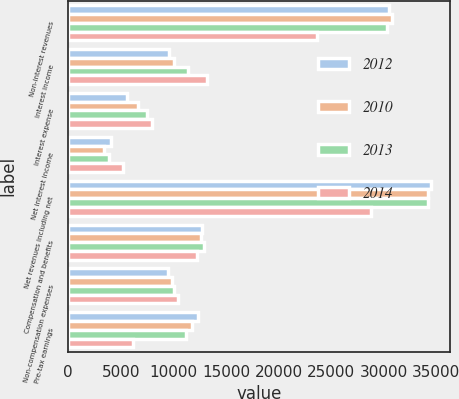Convert chart. <chart><loc_0><loc_0><loc_500><loc_500><stacked_bar_chart><ecel><fcel>Non-interest revenues<fcel>Interest income<fcel>Interest expense<fcel>Net interest income<fcel>Net revenues including net<fcel>Compensation and benefits<fcel>Non-compensation expenses<fcel>Pre-tax earnings<nl><fcel>2012<fcel>30481<fcel>9604<fcel>5557<fcel>4047<fcel>34528<fcel>12691<fcel>9480<fcel>12357<nl><fcel>2010<fcel>30814<fcel>10060<fcel>6668<fcel>3392<fcel>34206<fcel>12613<fcel>9856<fcel>11737<nl><fcel>2013<fcel>30283<fcel>11381<fcel>7501<fcel>3880<fcel>34163<fcel>12944<fcel>10012<fcel>11207<nl><fcel>2014<fcel>23619<fcel>13174<fcel>7982<fcel>5192<fcel>28811<fcel>12223<fcel>10419<fcel>6169<nl></chart> 